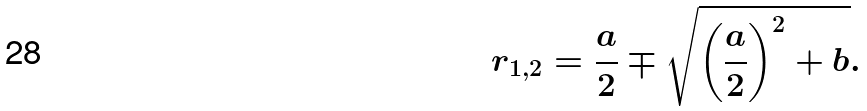Convert formula to latex. <formula><loc_0><loc_0><loc_500><loc_500>r _ { 1 , 2 } = \frac { a } { 2 } \mp \sqrt { \left ( \frac { a } { 2 } \right ) ^ { 2 } + b } .</formula> 